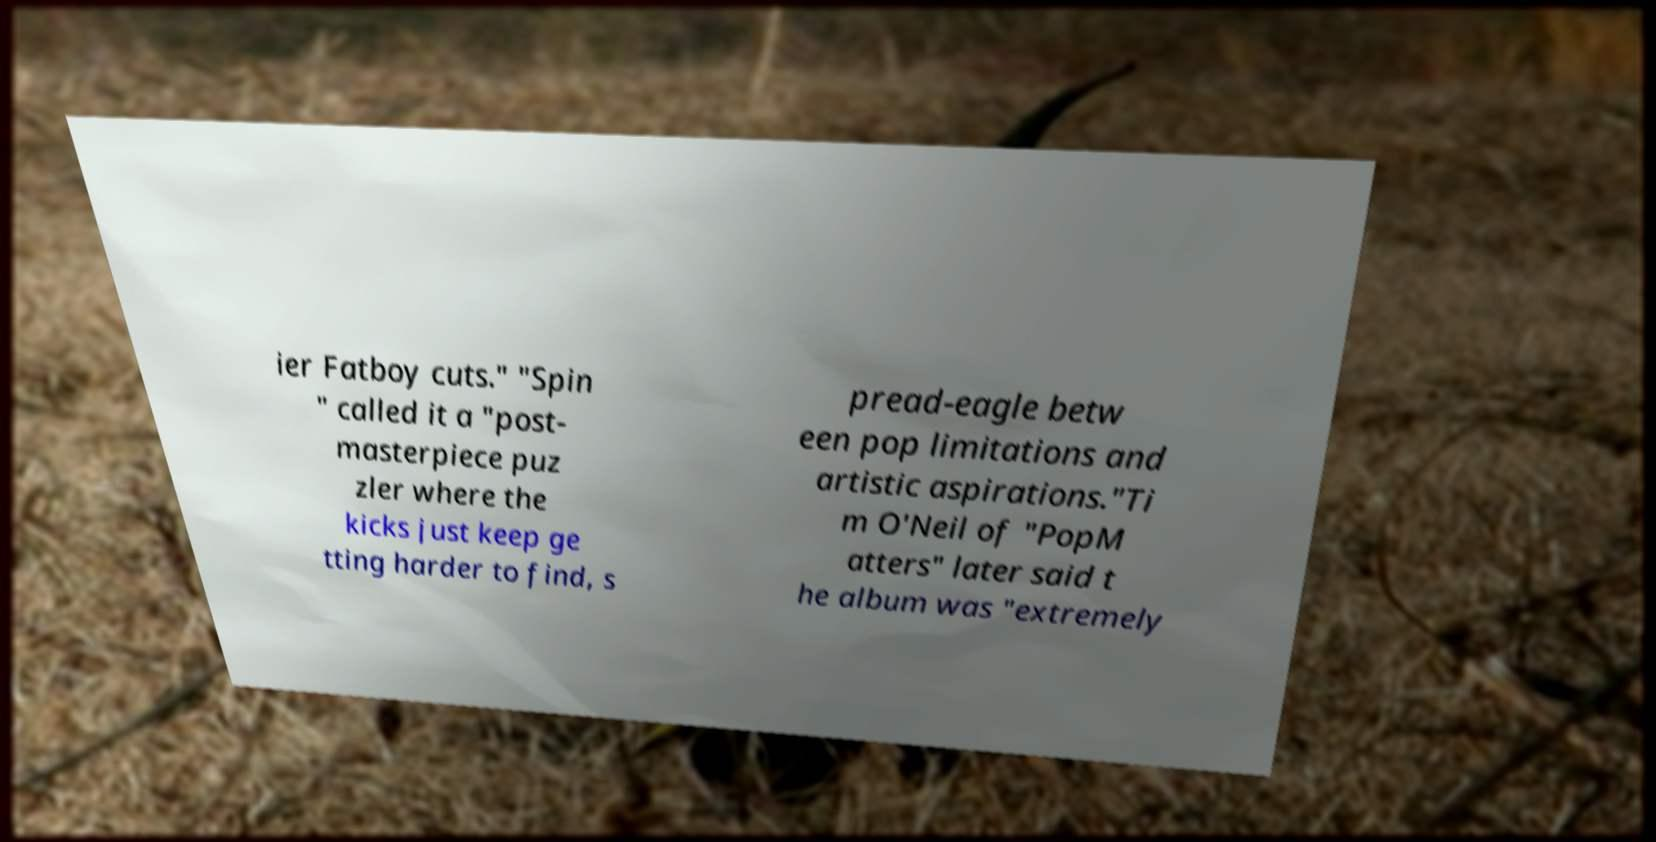I need the written content from this picture converted into text. Can you do that? ier Fatboy cuts." "Spin " called it a "post- masterpiece puz zler where the kicks just keep ge tting harder to find, s pread-eagle betw een pop limitations and artistic aspirations."Ti m O'Neil of "PopM atters" later said t he album was "extremely 